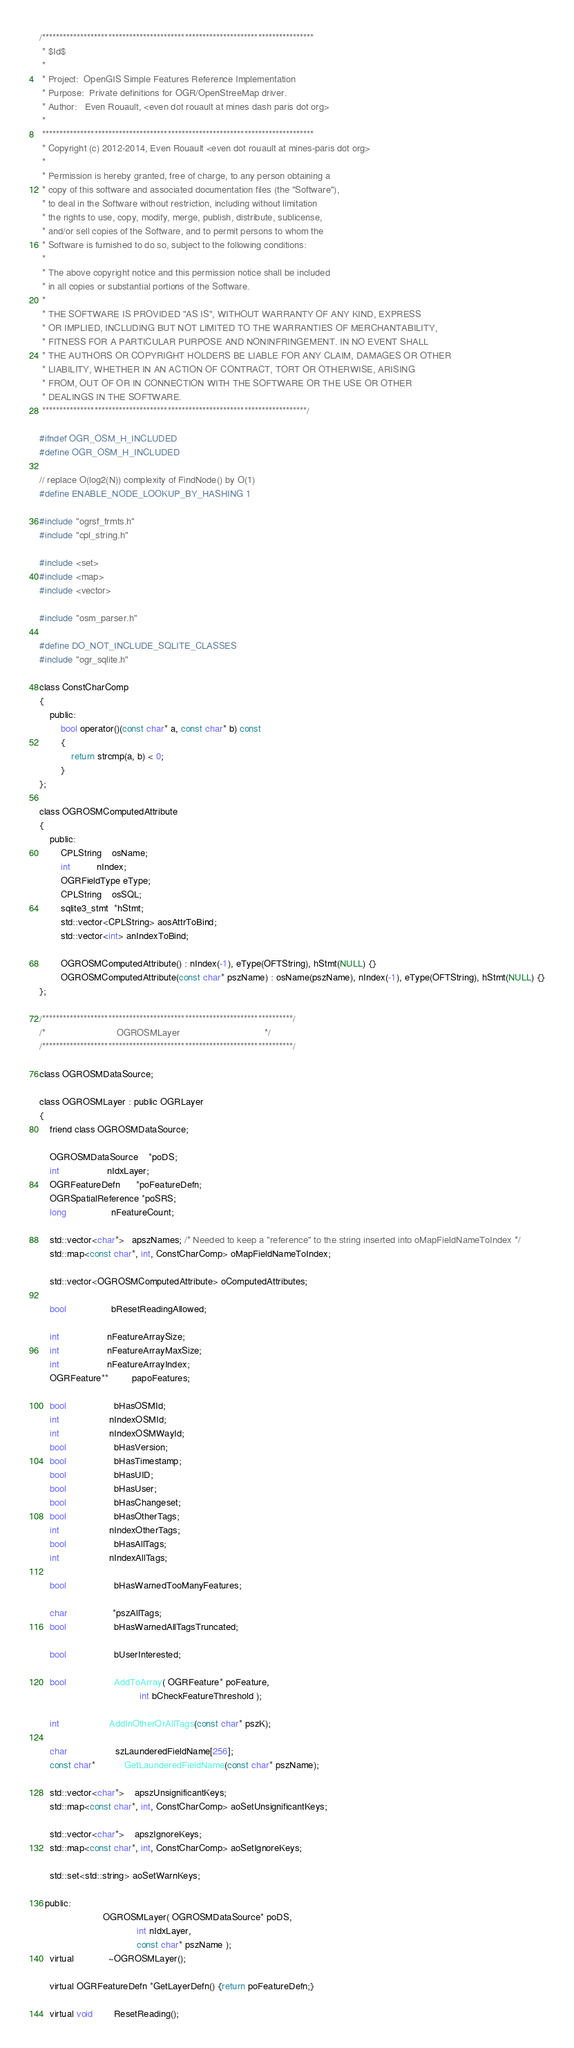Convert code to text. <code><loc_0><loc_0><loc_500><loc_500><_C_>/******************************************************************************
 * $Id$
 *
 * Project:  OpenGIS Simple Features Reference Implementation
 * Purpose:  Private definitions for OGR/OpenStreeMap driver.
 * Author:   Even Rouault, <even dot rouault at mines dash paris dot org>
 *
 ******************************************************************************
 * Copyright (c) 2012-2014, Even Rouault <even dot rouault at mines-paris dot org>
 *
 * Permission is hereby granted, free of charge, to any person obtaining a
 * copy of this software and associated documentation files (the "Software"),
 * to deal in the Software without restriction, including without limitation
 * the rights to use, copy, modify, merge, publish, distribute, sublicense,
 * and/or sell copies of the Software, and to permit persons to whom the
 * Software is furnished to do so, subject to the following conditions:
 *
 * The above copyright notice and this permission notice shall be included
 * in all copies or substantial portions of the Software.
 *
 * THE SOFTWARE IS PROVIDED "AS IS", WITHOUT WARRANTY OF ANY KIND, EXPRESS
 * OR IMPLIED, INCLUDING BUT NOT LIMITED TO THE WARRANTIES OF MERCHANTABILITY,
 * FITNESS FOR A PARTICULAR PURPOSE AND NONINFRINGEMENT. IN NO EVENT SHALL
 * THE AUTHORS OR COPYRIGHT HOLDERS BE LIABLE FOR ANY CLAIM, DAMAGES OR OTHER
 * LIABILITY, WHETHER IN AN ACTION OF CONTRACT, TORT OR OTHERWISE, ARISING
 * FROM, OUT OF OR IN CONNECTION WITH THE SOFTWARE OR THE USE OR OTHER
 * DEALINGS IN THE SOFTWARE.
 ****************************************************************************/

#ifndef OGR_OSM_H_INCLUDED
#define OGR_OSM_H_INCLUDED

// replace O(log2(N)) complexity of FindNode() by O(1)
#define ENABLE_NODE_LOOKUP_BY_HASHING 1

#include "ogrsf_frmts.h"
#include "cpl_string.h"

#include <set>
#include <map>
#include <vector>

#include "osm_parser.h"

#define DO_NOT_INCLUDE_SQLITE_CLASSES
#include "ogr_sqlite.h"

class ConstCharComp
{
    public:
        bool operator()(const char* a, const char* b) const
        {
            return strcmp(a, b) < 0;
        }
};

class OGROSMComputedAttribute
{
    public:
        CPLString    osName;
        int          nIndex;
        OGRFieldType eType;
        CPLString    osSQL;
        sqlite3_stmt  *hStmt;
        std::vector<CPLString> aosAttrToBind;
        std::vector<int> anIndexToBind;

        OGROSMComputedAttribute() : nIndex(-1), eType(OFTString), hStmt(NULL) {}
        OGROSMComputedAttribute(const char* pszName) : osName(pszName), nIndex(-1), eType(OFTString), hStmt(NULL) {}
};

/************************************************************************/
/*                           OGROSMLayer                                */
/************************************************************************/

class OGROSMDataSource;

class OGROSMLayer : public OGRLayer
{
    friend class OGROSMDataSource;

    OGROSMDataSource    *poDS;
    int                  nIdxLayer;
    OGRFeatureDefn      *poFeatureDefn;
    OGRSpatialReference *poSRS;
    long                 nFeatureCount;

    std::vector<char*>   apszNames; /* Needed to keep a "reference" to the string inserted into oMapFieldNameToIndex */
    std::map<const char*, int, ConstCharComp> oMapFieldNameToIndex;

    std::vector<OGROSMComputedAttribute> oComputedAttributes;

    bool                 bResetReadingAllowed;

    int                  nFeatureArraySize;
    int                  nFeatureArrayMaxSize;
    int                  nFeatureArrayIndex;
    OGRFeature**         papoFeatures;

    bool                  bHasOSMId;
    int                   nIndexOSMId;
    int                   nIndexOSMWayId;
    bool                  bHasVersion;
    bool                  bHasTimestamp;
    bool                  bHasUID;
    bool                  bHasUser;
    bool                  bHasChangeset;
    bool                  bHasOtherTags;
    int                   nIndexOtherTags;
    bool                  bHasAllTags;
    int                   nIndexAllTags;

    bool                  bHasWarnedTooManyFeatures;

    char                 *pszAllTags;
    bool                  bHasWarnedAllTagsTruncated;

    bool                  bUserInterested;

    bool                  AddToArray( OGRFeature* poFeature,
                                      int bCheckFeatureThreshold );

    int                   AddInOtherOrAllTags(const char* pszK);

    char                  szLaunderedFieldName[256];
    const char*           GetLaunderedFieldName(const char* pszName);

    std::vector<char*>    apszUnsignificantKeys;
    std::map<const char*, int, ConstCharComp> aoSetUnsignificantKeys;

    std::vector<char*>    apszIgnoreKeys;
    std::map<const char*, int, ConstCharComp> aoSetIgnoreKeys;

    std::set<std::string> aoSetWarnKeys;

  public:
                        OGROSMLayer( OGROSMDataSource* poDS,
                                     int nIdxLayer,
                                     const char* pszName );
    virtual             ~OGROSMLayer();

    virtual OGRFeatureDefn *GetLayerDefn() {return poFeatureDefn;}

    virtual void        ResetReading();</code> 